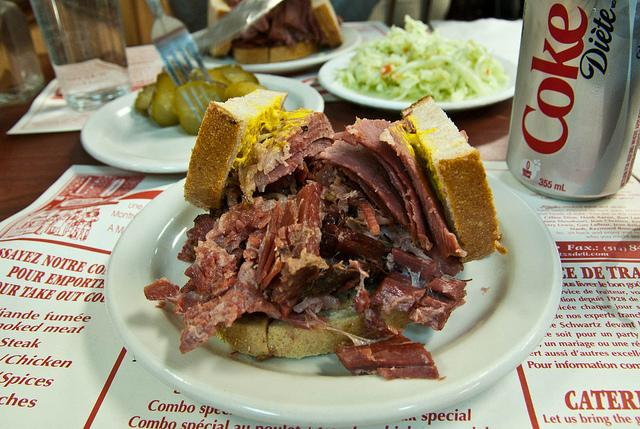What type of sandwich is this?

Choices:
A) turkey
B) monte cristo
C) blt
D) corned beef corned beef 